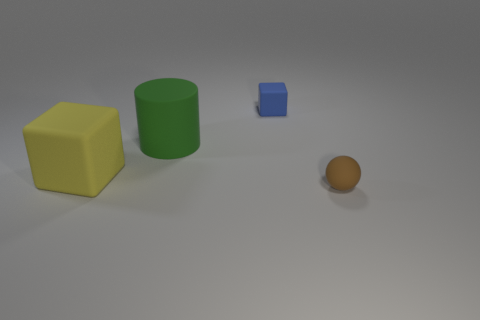Add 4 large green matte cylinders. How many objects exist? 8 Subtract 1 balls. How many balls are left? 0 Subtract all cyan cubes. Subtract all gray cylinders. How many cubes are left? 2 Subtract all purple cylinders. How many blue blocks are left? 1 Subtract all blue matte things. Subtract all big green shiny cylinders. How many objects are left? 3 Add 4 small blue matte cubes. How many small blue matte cubes are left? 5 Add 4 tiny blue things. How many tiny blue things exist? 5 Subtract 0 gray cylinders. How many objects are left? 4 